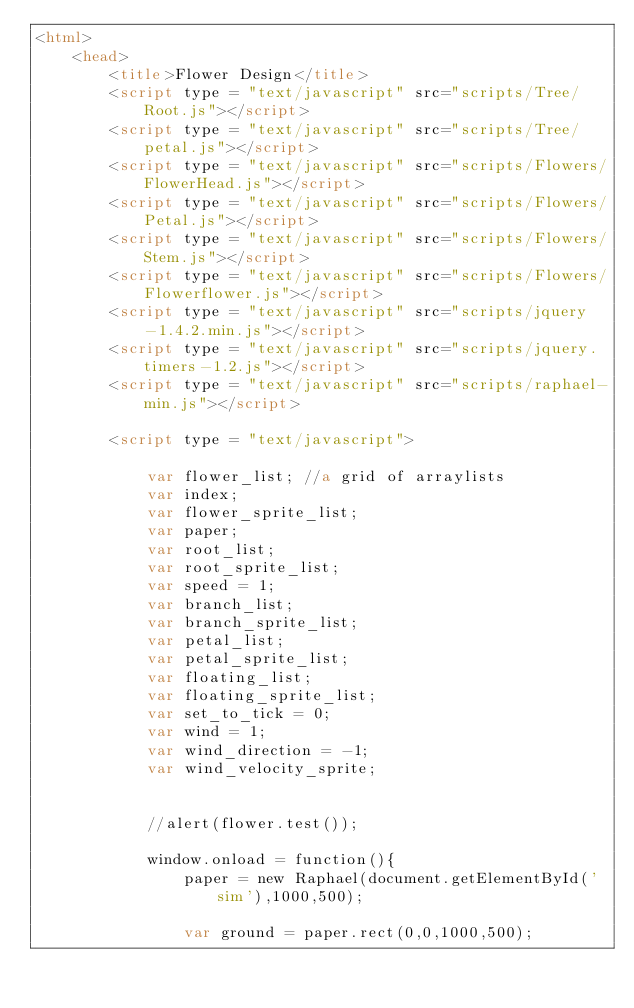<code> <loc_0><loc_0><loc_500><loc_500><_HTML_><html>
	<head>
		<title>Flower Design</title>
		<script type = "text/javascript" src="scripts/Tree/Root.js"></script>
		<script type = "text/javascript" src="scripts/Tree/petal.js"></script>
		<script type = "text/javascript" src="scripts/Flowers/FlowerHead.js"></script>
		<script type = "text/javascript" src="scripts/Flowers/Petal.js"></script>
		<script type = "text/javascript" src="scripts/Flowers/Stem.js"></script>
		<script type = "text/javascript" src="scripts/Flowers/Flowerflower.js"></script>
		<script type = "text/javascript" src="scripts/jquery-1.4.2.min.js"></script>
		<script type = "text/javascript" src="scripts/jquery.timers-1.2.js"></script>
		<script type = "text/javascript" src="scripts/raphael-min.js"></script>
		
		<script type = "text/javascript">
		
			var flower_list; //a grid of arraylists
			var index;
			var flower_sprite_list;
			var paper;
			var root_list;
			var root_sprite_list;
			var speed = 1;
			var branch_list;
			var branch_sprite_list;
			var petal_list;
			var petal_sprite_list;
			var floating_list;
			var floating_sprite_list;
			var set_to_tick = 0;
			var wind = 1;
			var wind_direction = -1;
			var wind_velocity_sprite;
			
	
			//alert(flower.test());
			
			window.onload = function(){
				paper = new Raphael(document.getElementById('sim'),1000,500);
				
				var ground = paper.rect(0,0,1000,500);</code> 